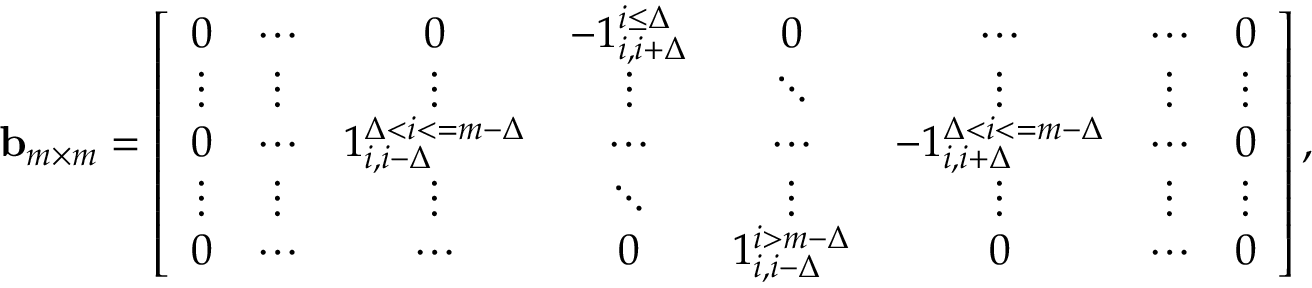<formula> <loc_0><loc_0><loc_500><loc_500>\begin{array} { r l } & { b _ { m \times m } = \left [ \begin{array} { c c c c c c c c } { 0 } & { \cdots } & { 0 } & { - 1 _ { i , i + \Delta } ^ { i \leq \Delta } } & { 0 } & { \cdots } & { \cdots } & { 0 } \\ { \vdots } & { \vdots } & { \vdots } & { \vdots } & { \ddots } & { \vdots } & { \vdots } & { \vdots } \\ { 0 } & { \cdots } & { 1 _ { i , i - \Delta } ^ { \Delta < i < = m - \Delta } } & { \cdots } & { \cdots } & { - 1 _ { i , i + \Delta } ^ { \Delta < i < = m - \Delta } } & { \cdots } & { 0 } \\ { \vdots } & { \vdots } & { \vdots } & { \ddots } & { \vdots } & { \vdots } & { \vdots } & { \vdots } \\ { 0 } & { \cdots } & { \cdots } & { 0 } & { 1 _ { i , i - \Delta } ^ { i > m - \Delta } } & { 0 } & { \cdots } & { 0 } \end{array} \right ] , } \end{array}</formula> 